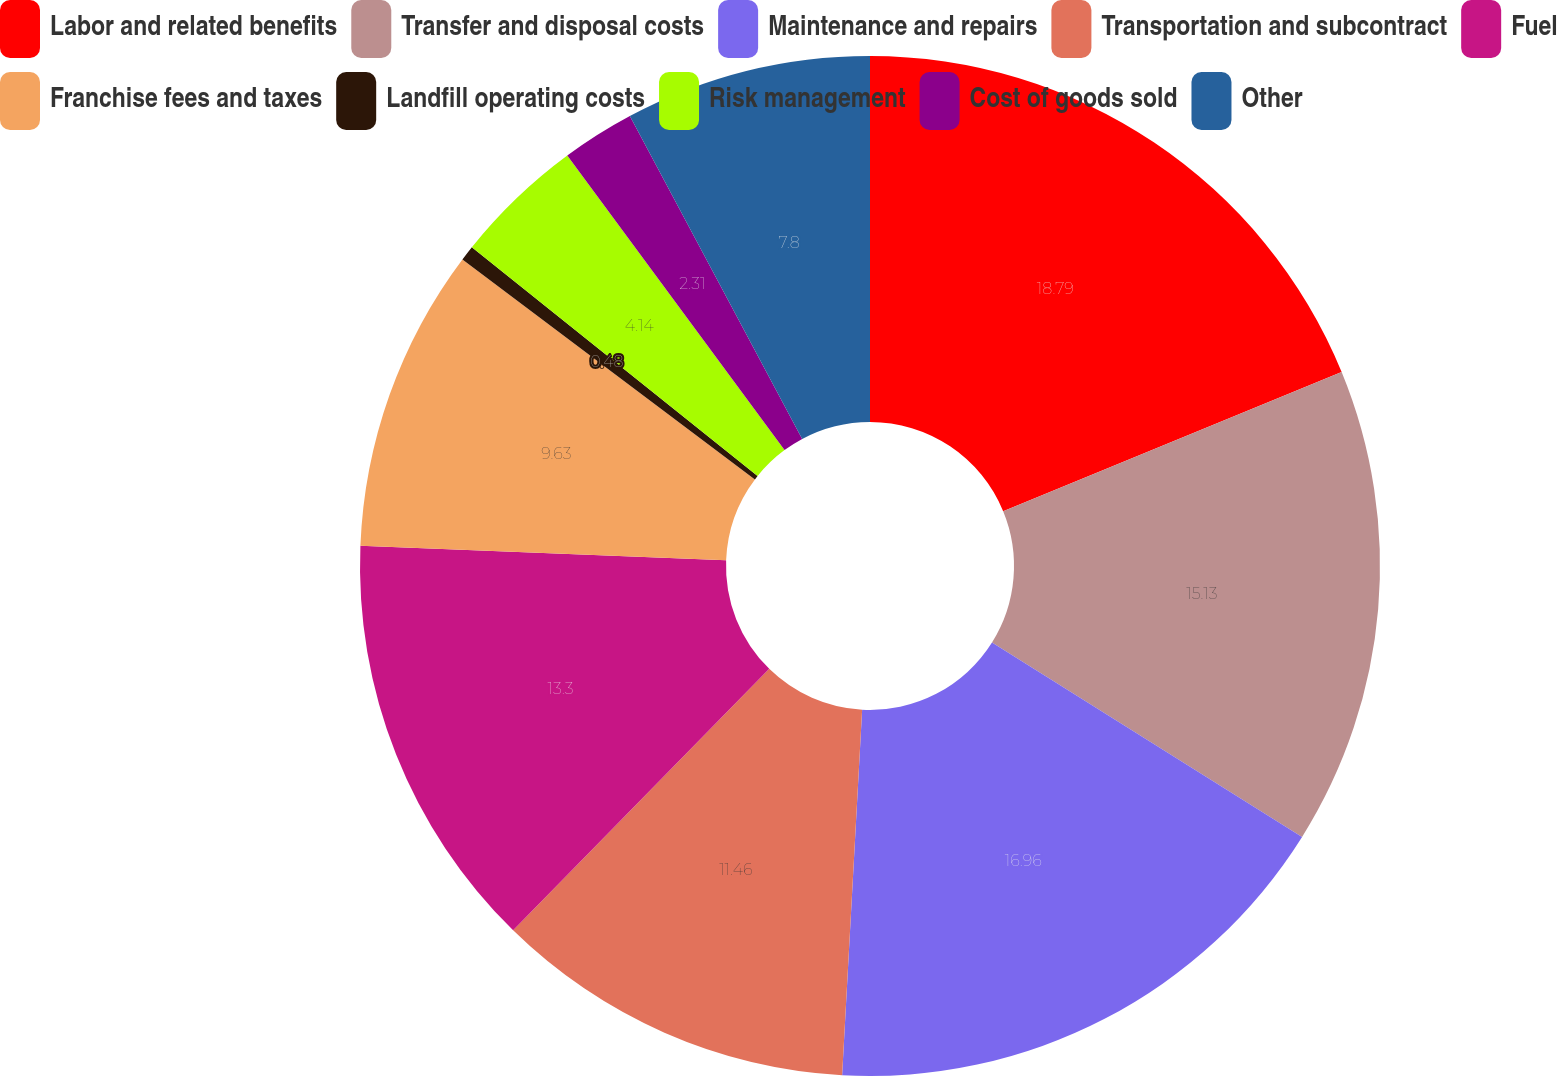<chart> <loc_0><loc_0><loc_500><loc_500><pie_chart><fcel>Labor and related benefits<fcel>Transfer and disposal costs<fcel>Maintenance and repairs<fcel>Transportation and subcontract<fcel>Fuel<fcel>Franchise fees and taxes<fcel>Landfill operating costs<fcel>Risk management<fcel>Cost of goods sold<fcel>Other<nl><fcel>18.78%<fcel>15.12%<fcel>16.95%<fcel>11.46%<fcel>13.29%<fcel>9.63%<fcel>0.48%<fcel>4.14%<fcel>2.31%<fcel>7.8%<nl></chart> 